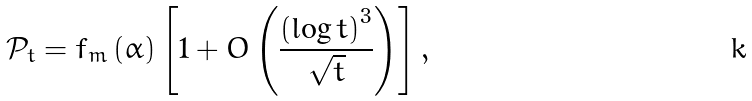<formula> <loc_0><loc_0><loc_500><loc_500>\mathcal { P } _ { t } = f _ { m } \left ( \alpha \right ) \left [ 1 + O \left ( \frac { \left ( \log t \right ) ^ { 3 } } { \sqrt { t } } \right ) \right ] ,</formula> 